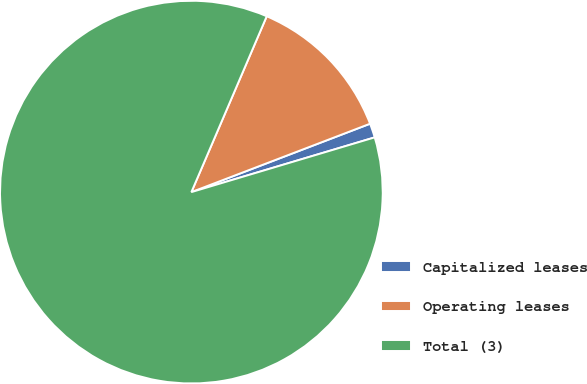Convert chart. <chart><loc_0><loc_0><loc_500><loc_500><pie_chart><fcel>Capitalized leases<fcel>Operating leases<fcel>Total (3)<nl><fcel>1.2%<fcel>12.74%<fcel>86.06%<nl></chart> 